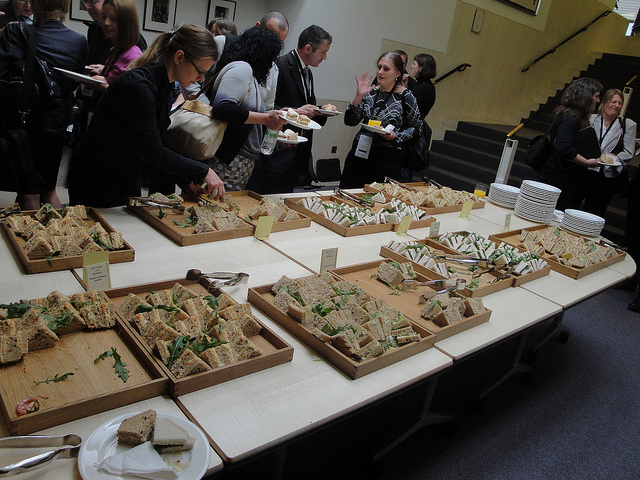<image>What kind of sandwiches are those? I don't know what kind of sandwiches these are. They could be tuna fish, club sandwiches, or finger sandwiches. What kind of sandwiches are those? I don't know what kind of sandwiches are those. It can be either tuna fish, club sandwiches, finger sandwiches, or mini sandwiches. 